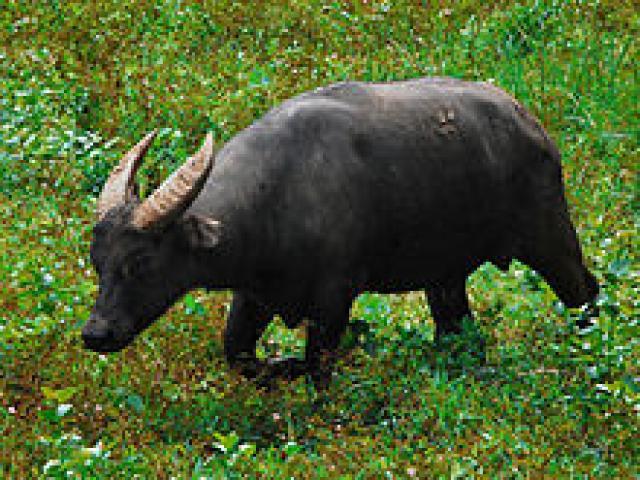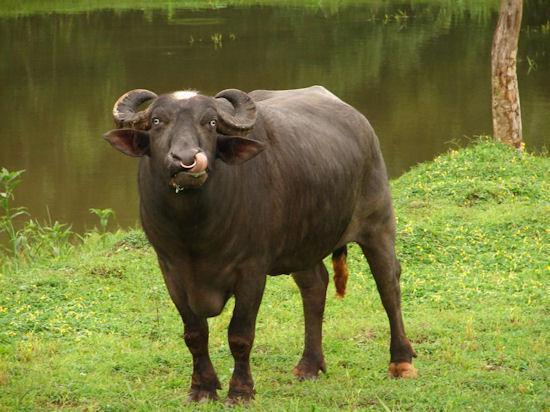The first image is the image on the left, the second image is the image on the right. Evaluate the accuracy of this statement regarding the images: "The cow in the image on the right is near a watery area.". Is it true? Answer yes or no. Yes. The first image is the image on the left, the second image is the image on the right. For the images displayed, is the sentence "An image shows at least one forward-looking ox with a rope threaded through its nose, standing in a wet, muddy area." factually correct? Answer yes or no. No. 